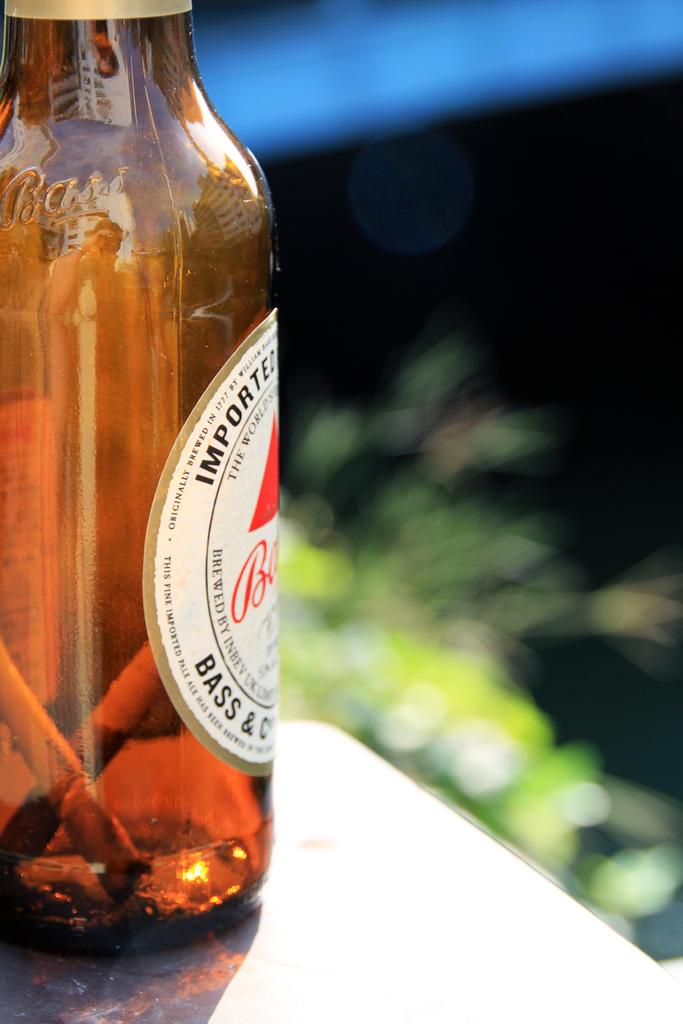What brand is this beer?
Keep it short and to the point. Bass. 